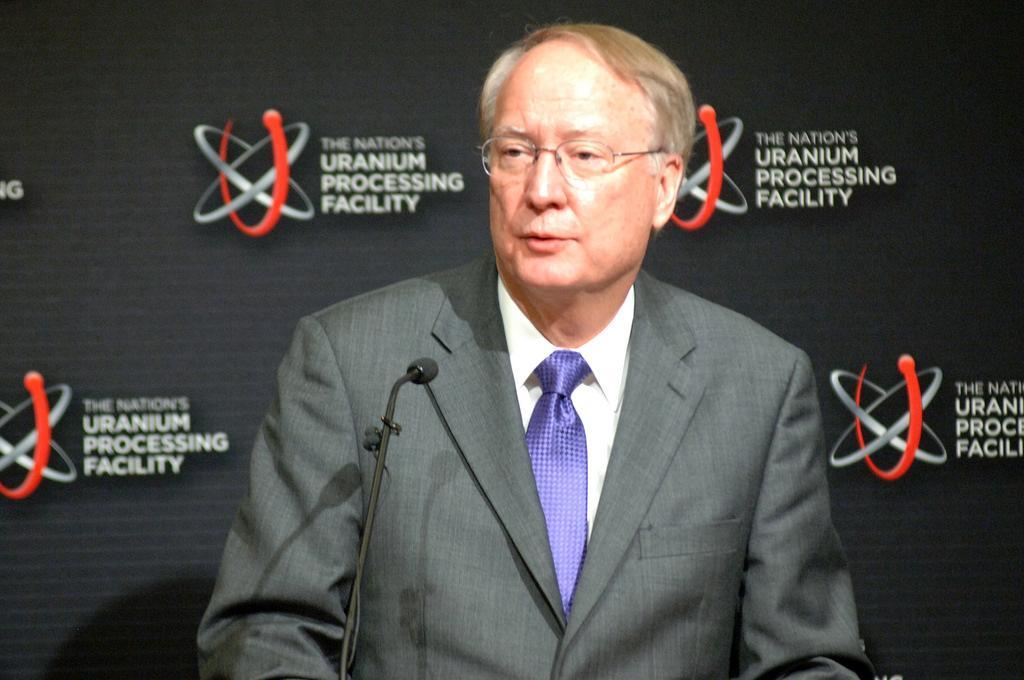In one or two sentences, can you explain what this image depicts? In the foreground I can see a person in front of a mike in suit. In the background I can see a curtain and a logo. This image is taken may be in a hall. 